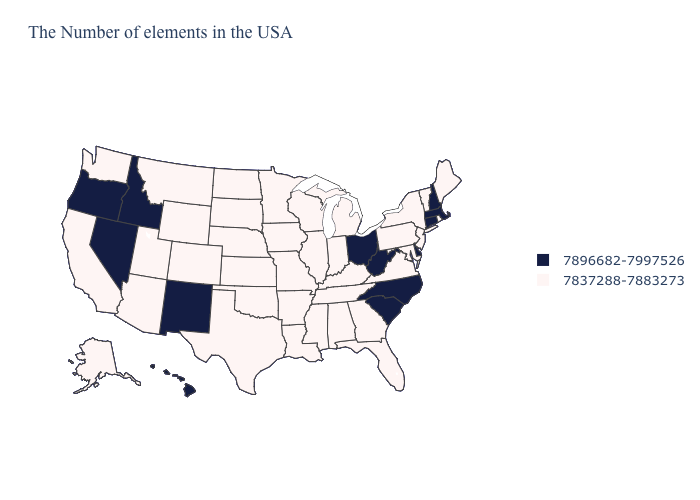Does Washington have a lower value than Mississippi?
Concise answer only. No. What is the value of Virginia?
Answer briefly. 7837288-7883273. Name the states that have a value in the range 7896682-7997526?
Give a very brief answer. Massachusetts, New Hampshire, Connecticut, Delaware, North Carolina, South Carolina, West Virginia, Ohio, New Mexico, Idaho, Nevada, Oregon, Hawaii. Which states have the highest value in the USA?
Answer briefly. Massachusetts, New Hampshire, Connecticut, Delaware, North Carolina, South Carolina, West Virginia, Ohio, New Mexico, Idaho, Nevada, Oregon, Hawaii. What is the value of Delaware?
Short answer required. 7896682-7997526. Does Vermont have the lowest value in the Northeast?
Short answer required. Yes. How many symbols are there in the legend?
Be succinct. 2. Which states hav the highest value in the Northeast?
Be succinct. Massachusetts, New Hampshire, Connecticut. How many symbols are there in the legend?
Quick response, please. 2. Among the states that border North Carolina , does South Carolina have the highest value?
Be succinct. Yes. Does Rhode Island have the lowest value in the Northeast?
Be succinct. Yes. What is the value of Arkansas?
Short answer required. 7837288-7883273. Does New Hampshire have the highest value in the Northeast?
Keep it brief. Yes. What is the lowest value in the Northeast?
Concise answer only. 7837288-7883273. What is the value of Texas?
Give a very brief answer. 7837288-7883273. 